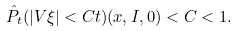<formula> <loc_0><loc_0><loc_500><loc_500>\hat { P } _ { t } ( | V \xi | < C t ) ( x , I , 0 ) < C < 1 .</formula> 